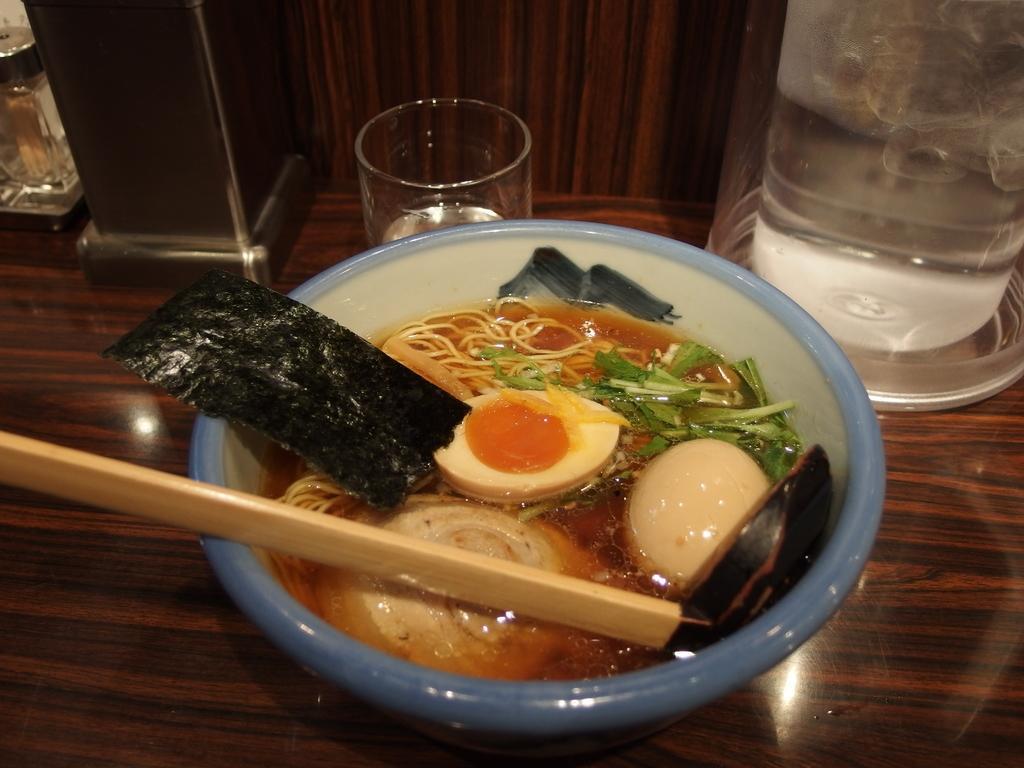How would you summarize this image in a sentence or two? In the image there are some cooked food items kept in a bowl along with the soup and around the bowl there is a glass and other objects. 